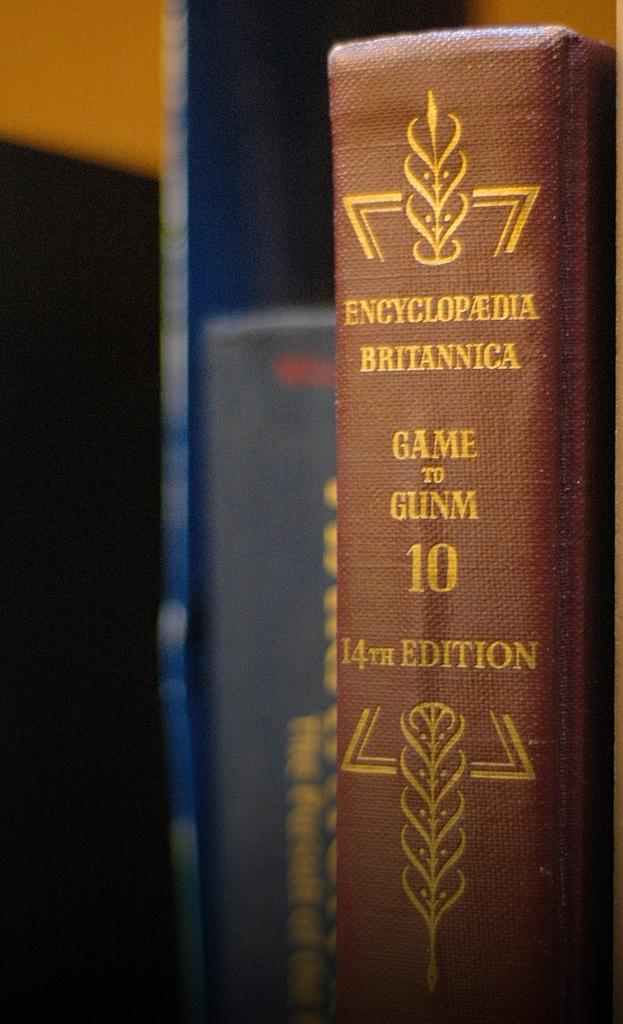Provide a one-sentence caption for the provided image. Book number 10 in the 14th edition of the Encyclopedia Britannica sits next to another book. 